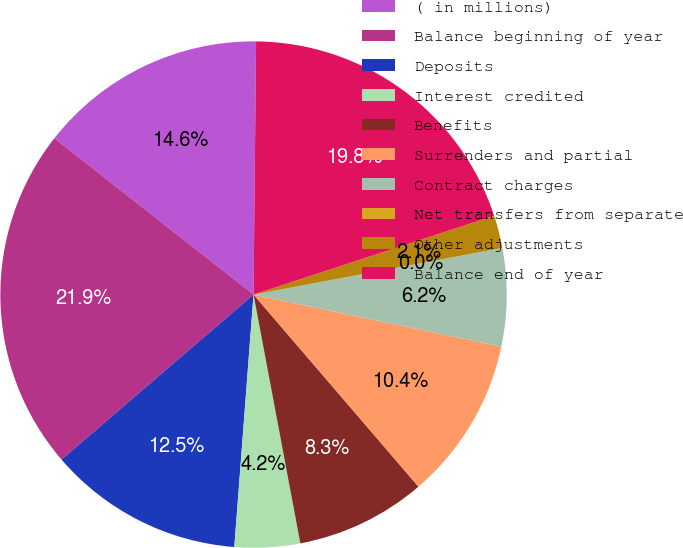<chart> <loc_0><loc_0><loc_500><loc_500><pie_chart><fcel>( in millions)<fcel>Balance beginning of year<fcel>Deposits<fcel>Interest credited<fcel>Benefits<fcel>Surrenders and partial<fcel>Contract charges<fcel>Net transfers from separate<fcel>Other adjustments<fcel>Balance end of year<nl><fcel>14.57%<fcel>21.89%<fcel>12.49%<fcel>4.17%<fcel>8.33%<fcel>10.41%<fcel>6.25%<fcel>0.0%<fcel>2.09%<fcel>19.8%<nl></chart> 